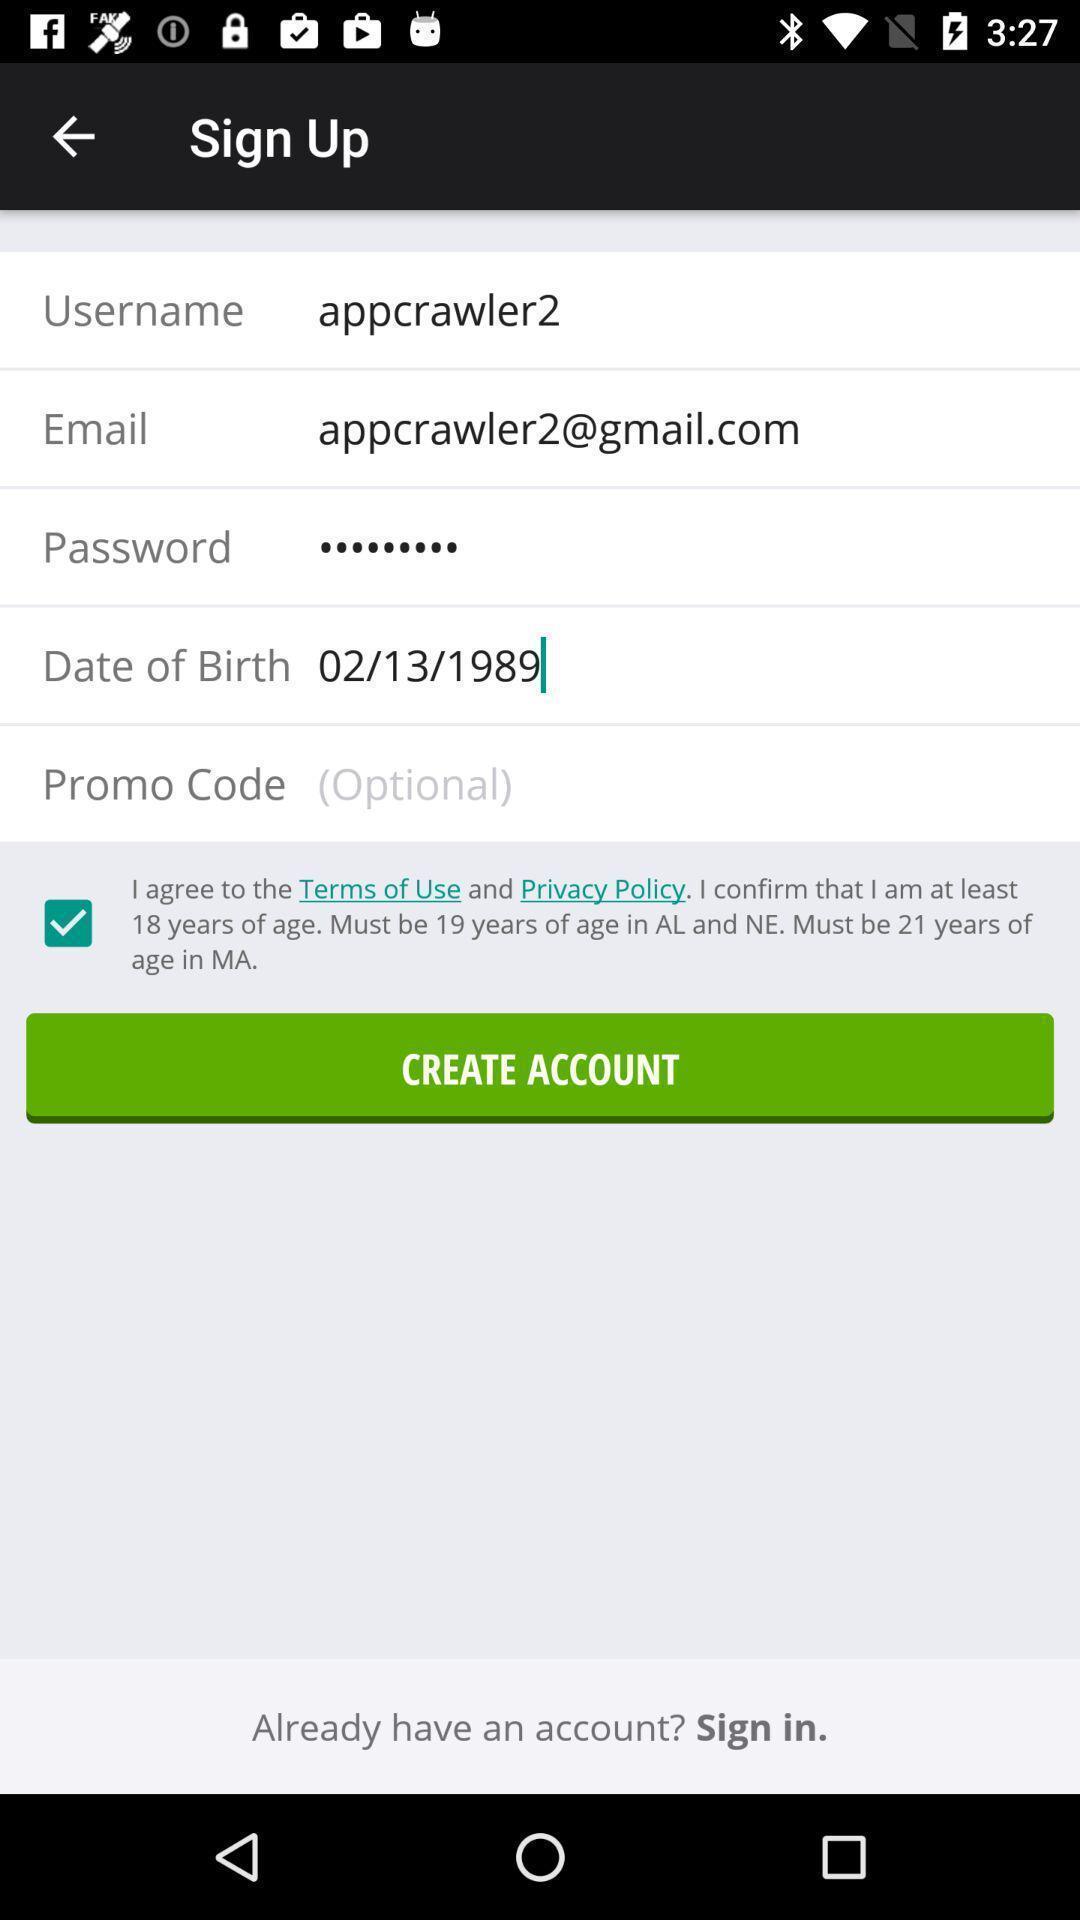Give me a narrative description of this picture. Sign up page with create account option. 